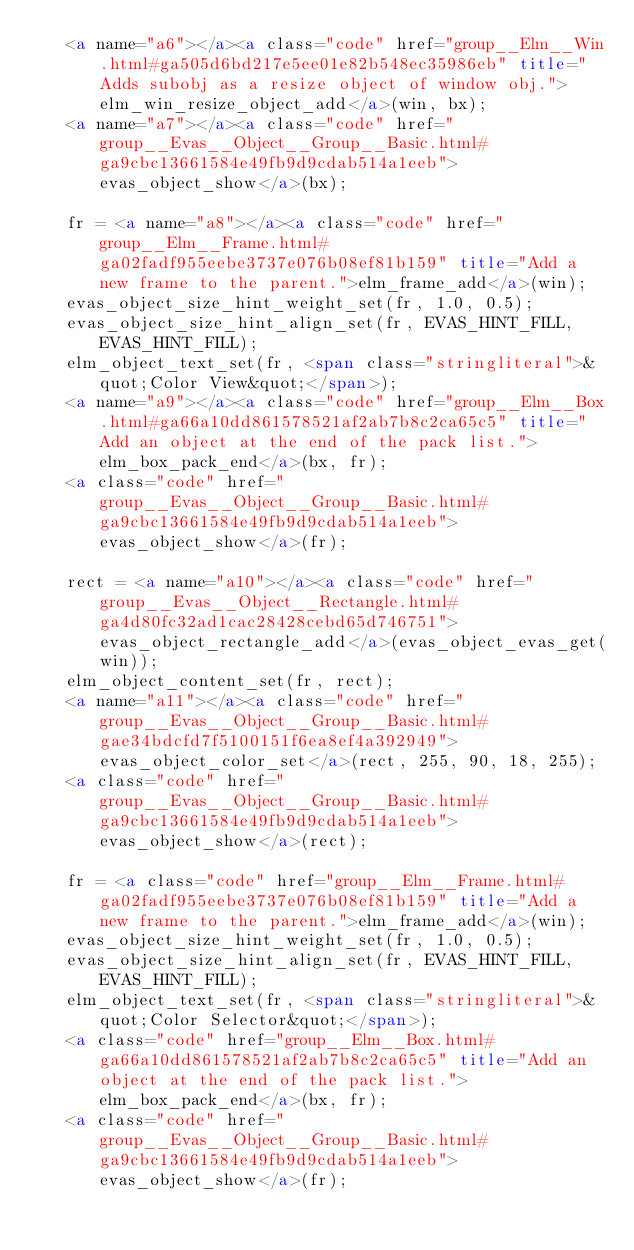<code> <loc_0><loc_0><loc_500><loc_500><_HTML_>   <a name="a6"></a><a class="code" href="group__Elm__Win.html#ga505d6bd217e5ee01e82b548ec35986eb" title="Adds subobj as a resize object of window obj.">elm_win_resize_object_add</a>(win, bx);
   <a name="a7"></a><a class="code" href="group__Evas__Object__Group__Basic.html#ga9cbc13661584e49fb9d9cdab514a1eeb">evas_object_show</a>(bx);

   fr = <a name="a8"></a><a class="code" href="group__Elm__Frame.html#ga02fadf955eebe3737e076b08ef81b159" title="Add a new frame to the parent.">elm_frame_add</a>(win);
   evas_object_size_hint_weight_set(fr, 1.0, 0.5);
   evas_object_size_hint_align_set(fr, EVAS_HINT_FILL, EVAS_HINT_FILL);
   elm_object_text_set(fr, <span class="stringliteral">&quot;Color View&quot;</span>);
   <a name="a9"></a><a class="code" href="group__Elm__Box.html#ga66a10dd861578521af2ab7b8c2ca65c5" title="Add an object at the end of the pack list.">elm_box_pack_end</a>(bx, fr);
   <a class="code" href="group__Evas__Object__Group__Basic.html#ga9cbc13661584e49fb9d9cdab514a1eeb">evas_object_show</a>(fr);

   rect = <a name="a10"></a><a class="code" href="group__Evas__Object__Rectangle.html#ga4d80fc32ad1cac28428cebd65d746751">evas_object_rectangle_add</a>(evas_object_evas_get(win));
   elm_object_content_set(fr, rect);
   <a name="a11"></a><a class="code" href="group__Evas__Object__Group__Basic.html#gae34bdcfd7f5100151f6ea8ef4a392949">evas_object_color_set</a>(rect, 255, 90, 18, 255);
   <a class="code" href="group__Evas__Object__Group__Basic.html#ga9cbc13661584e49fb9d9cdab514a1eeb">evas_object_show</a>(rect);

   fr = <a class="code" href="group__Elm__Frame.html#ga02fadf955eebe3737e076b08ef81b159" title="Add a new frame to the parent.">elm_frame_add</a>(win);
   evas_object_size_hint_weight_set(fr, 1.0, 0.5);
   evas_object_size_hint_align_set(fr, EVAS_HINT_FILL, EVAS_HINT_FILL);
   elm_object_text_set(fr, <span class="stringliteral">&quot;Color Selector&quot;</span>);
   <a class="code" href="group__Elm__Box.html#ga66a10dd861578521af2ab7b8c2ca65c5" title="Add an object at the end of the pack list.">elm_box_pack_end</a>(bx, fr);
   <a class="code" href="group__Evas__Object__Group__Basic.html#ga9cbc13661584e49fb9d9cdab514a1eeb">evas_object_show</a>(fr);
</code> 